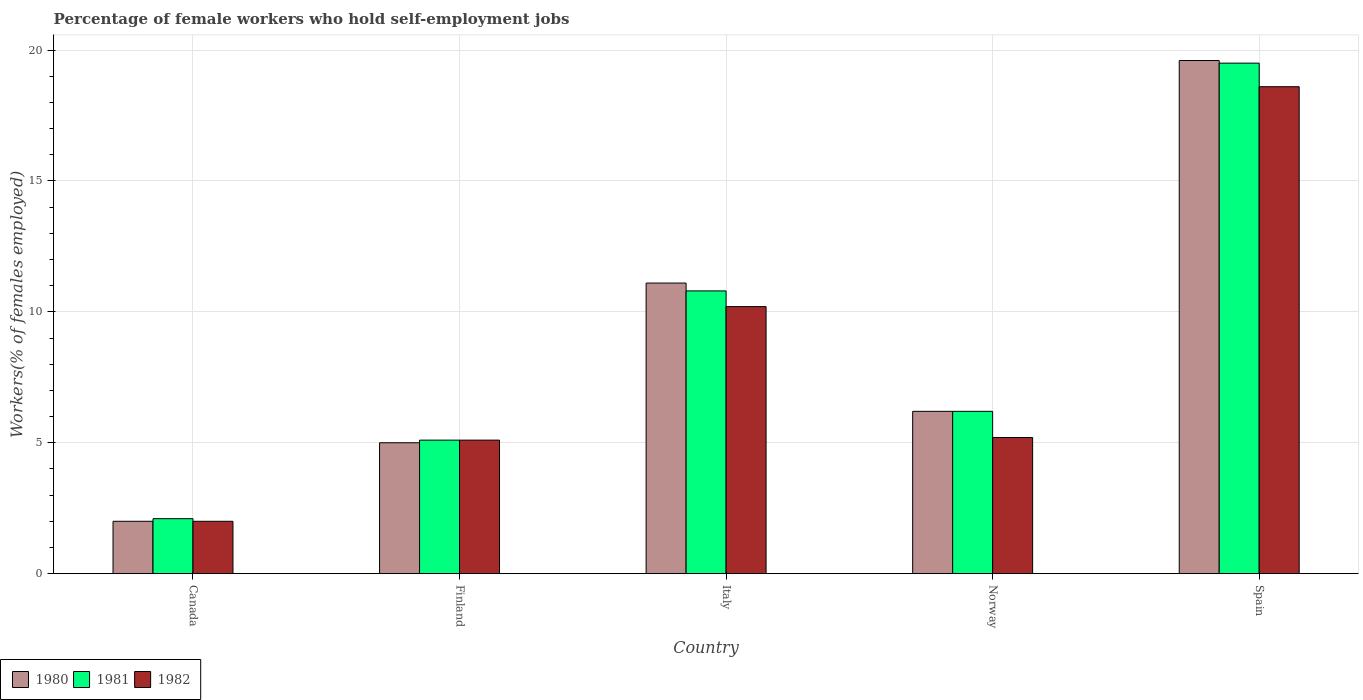Are the number of bars on each tick of the X-axis equal?
Provide a succinct answer. Yes. What is the label of the 2nd group of bars from the left?
Offer a very short reply. Finland. What is the percentage of self-employed female workers in 1980 in Norway?
Provide a succinct answer. 6.2. Across all countries, what is the maximum percentage of self-employed female workers in 1980?
Offer a very short reply. 19.6. Across all countries, what is the minimum percentage of self-employed female workers in 1981?
Provide a short and direct response. 2.1. What is the total percentage of self-employed female workers in 1980 in the graph?
Ensure brevity in your answer.  43.9. What is the difference between the percentage of self-employed female workers in 1980 in Norway and that in Spain?
Provide a succinct answer. -13.4. What is the difference between the percentage of self-employed female workers in 1981 in Spain and the percentage of self-employed female workers in 1980 in Finland?
Ensure brevity in your answer.  14.5. What is the average percentage of self-employed female workers in 1982 per country?
Your answer should be very brief. 8.22. What is the difference between the percentage of self-employed female workers of/in 1982 and percentage of self-employed female workers of/in 1981 in Norway?
Keep it short and to the point. -1. In how many countries, is the percentage of self-employed female workers in 1980 greater than 5 %?
Make the answer very short. 3. What is the ratio of the percentage of self-employed female workers in 1980 in Canada to that in Finland?
Your answer should be compact. 0.4. What is the difference between the highest and the second highest percentage of self-employed female workers in 1980?
Offer a very short reply. -8.5. What is the difference between the highest and the lowest percentage of self-employed female workers in 1981?
Your answer should be compact. 17.4. What does the 3rd bar from the right in Italy represents?
Provide a short and direct response. 1980. How many bars are there?
Offer a very short reply. 15. Are the values on the major ticks of Y-axis written in scientific E-notation?
Give a very brief answer. No. What is the title of the graph?
Offer a terse response. Percentage of female workers who hold self-employment jobs. Does "1974" appear as one of the legend labels in the graph?
Provide a short and direct response. No. What is the label or title of the Y-axis?
Give a very brief answer. Workers(% of females employed). What is the Workers(% of females employed) of 1980 in Canada?
Your answer should be very brief. 2. What is the Workers(% of females employed) of 1981 in Canada?
Make the answer very short. 2.1. What is the Workers(% of females employed) of 1982 in Canada?
Ensure brevity in your answer.  2. What is the Workers(% of females employed) in 1980 in Finland?
Ensure brevity in your answer.  5. What is the Workers(% of females employed) in 1981 in Finland?
Give a very brief answer. 5.1. What is the Workers(% of females employed) in 1982 in Finland?
Your response must be concise. 5.1. What is the Workers(% of females employed) of 1980 in Italy?
Offer a very short reply. 11.1. What is the Workers(% of females employed) of 1981 in Italy?
Your response must be concise. 10.8. What is the Workers(% of females employed) of 1982 in Italy?
Offer a terse response. 10.2. What is the Workers(% of females employed) of 1980 in Norway?
Keep it short and to the point. 6.2. What is the Workers(% of females employed) in 1981 in Norway?
Ensure brevity in your answer.  6.2. What is the Workers(% of females employed) in 1982 in Norway?
Keep it short and to the point. 5.2. What is the Workers(% of females employed) in 1980 in Spain?
Your answer should be compact. 19.6. What is the Workers(% of females employed) in 1981 in Spain?
Your response must be concise. 19.5. What is the Workers(% of females employed) in 1982 in Spain?
Provide a short and direct response. 18.6. Across all countries, what is the maximum Workers(% of females employed) in 1980?
Give a very brief answer. 19.6. Across all countries, what is the maximum Workers(% of females employed) of 1981?
Your response must be concise. 19.5. Across all countries, what is the maximum Workers(% of females employed) of 1982?
Keep it short and to the point. 18.6. Across all countries, what is the minimum Workers(% of females employed) of 1981?
Offer a terse response. 2.1. What is the total Workers(% of females employed) of 1980 in the graph?
Your response must be concise. 43.9. What is the total Workers(% of females employed) in 1981 in the graph?
Make the answer very short. 43.7. What is the total Workers(% of females employed) in 1982 in the graph?
Your answer should be compact. 41.1. What is the difference between the Workers(% of females employed) of 1980 in Canada and that in Italy?
Give a very brief answer. -9.1. What is the difference between the Workers(% of females employed) in 1981 in Canada and that in Italy?
Your response must be concise. -8.7. What is the difference between the Workers(% of females employed) of 1981 in Canada and that in Norway?
Your answer should be very brief. -4.1. What is the difference between the Workers(% of females employed) of 1980 in Canada and that in Spain?
Your response must be concise. -17.6. What is the difference between the Workers(% of females employed) in 1981 in Canada and that in Spain?
Your answer should be compact. -17.4. What is the difference between the Workers(% of females employed) of 1982 in Canada and that in Spain?
Your answer should be very brief. -16.6. What is the difference between the Workers(% of females employed) of 1981 in Finland and that in Italy?
Keep it short and to the point. -5.7. What is the difference between the Workers(% of females employed) in 1980 in Finland and that in Norway?
Your answer should be very brief. -1.2. What is the difference between the Workers(% of females employed) in 1981 in Finland and that in Norway?
Offer a terse response. -1.1. What is the difference between the Workers(% of females employed) in 1980 in Finland and that in Spain?
Your answer should be compact. -14.6. What is the difference between the Workers(% of females employed) in 1981 in Finland and that in Spain?
Keep it short and to the point. -14.4. What is the difference between the Workers(% of females employed) in 1982 in Finland and that in Spain?
Offer a terse response. -13.5. What is the difference between the Workers(% of females employed) of 1980 in Italy and that in Norway?
Offer a very short reply. 4.9. What is the difference between the Workers(% of females employed) in 1982 in Italy and that in Spain?
Offer a terse response. -8.4. What is the difference between the Workers(% of females employed) of 1982 in Norway and that in Spain?
Offer a terse response. -13.4. What is the difference between the Workers(% of females employed) of 1980 in Canada and the Workers(% of females employed) of 1981 in Finland?
Keep it short and to the point. -3.1. What is the difference between the Workers(% of females employed) of 1981 in Canada and the Workers(% of females employed) of 1982 in Finland?
Provide a short and direct response. -3. What is the difference between the Workers(% of females employed) in 1980 in Canada and the Workers(% of females employed) in 1981 in Norway?
Make the answer very short. -4.2. What is the difference between the Workers(% of females employed) of 1980 in Canada and the Workers(% of females employed) of 1982 in Norway?
Your answer should be compact. -3.2. What is the difference between the Workers(% of females employed) in 1980 in Canada and the Workers(% of females employed) in 1981 in Spain?
Your answer should be very brief. -17.5. What is the difference between the Workers(% of females employed) of 1980 in Canada and the Workers(% of females employed) of 1982 in Spain?
Make the answer very short. -16.6. What is the difference between the Workers(% of females employed) in 1981 in Canada and the Workers(% of females employed) in 1982 in Spain?
Keep it short and to the point. -16.5. What is the difference between the Workers(% of females employed) in 1980 in Finland and the Workers(% of females employed) in 1982 in Norway?
Provide a short and direct response. -0.2. What is the difference between the Workers(% of females employed) of 1981 in Finland and the Workers(% of females employed) of 1982 in Norway?
Your answer should be compact. -0.1. What is the difference between the Workers(% of females employed) in 1980 in Finland and the Workers(% of females employed) in 1982 in Spain?
Your response must be concise. -13.6. What is the difference between the Workers(% of females employed) of 1981 in Finland and the Workers(% of females employed) of 1982 in Spain?
Ensure brevity in your answer.  -13.5. What is the difference between the Workers(% of females employed) in 1980 in Italy and the Workers(% of females employed) in 1981 in Norway?
Your answer should be compact. 4.9. What is the difference between the Workers(% of females employed) in 1980 in Italy and the Workers(% of females employed) in 1982 in Norway?
Provide a succinct answer. 5.9. What is the difference between the Workers(% of females employed) in 1980 in Italy and the Workers(% of females employed) in 1981 in Spain?
Your response must be concise. -8.4. What is the difference between the Workers(% of females employed) of 1980 in Italy and the Workers(% of females employed) of 1982 in Spain?
Your answer should be very brief. -7.5. What is the difference between the Workers(% of females employed) of 1980 in Norway and the Workers(% of females employed) of 1982 in Spain?
Your answer should be compact. -12.4. What is the difference between the Workers(% of females employed) in 1981 in Norway and the Workers(% of females employed) in 1982 in Spain?
Ensure brevity in your answer.  -12.4. What is the average Workers(% of females employed) in 1980 per country?
Ensure brevity in your answer.  8.78. What is the average Workers(% of females employed) in 1981 per country?
Provide a succinct answer. 8.74. What is the average Workers(% of females employed) in 1982 per country?
Offer a very short reply. 8.22. What is the difference between the Workers(% of females employed) of 1980 and Workers(% of females employed) of 1981 in Canada?
Give a very brief answer. -0.1. What is the difference between the Workers(% of females employed) of 1980 and Workers(% of females employed) of 1982 in Canada?
Ensure brevity in your answer.  0. What is the difference between the Workers(% of females employed) of 1981 and Workers(% of females employed) of 1982 in Canada?
Provide a succinct answer. 0.1. What is the difference between the Workers(% of females employed) of 1980 and Workers(% of females employed) of 1981 in Finland?
Make the answer very short. -0.1. What is the difference between the Workers(% of females employed) in 1980 and Workers(% of females employed) in 1981 in Italy?
Your answer should be very brief. 0.3. What is the difference between the Workers(% of females employed) in 1980 and Workers(% of females employed) in 1982 in Italy?
Give a very brief answer. 0.9. What is the difference between the Workers(% of females employed) in 1981 and Workers(% of females employed) in 1982 in Norway?
Ensure brevity in your answer.  1. What is the difference between the Workers(% of females employed) of 1980 and Workers(% of females employed) of 1982 in Spain?
Offer a terse response. 1. What is the difference between the Workers(% of females employed) in 1981 and Workers(% of females employed) in 1982 in Spain?
Your answer should be very brief. 0.9. What is the ratio of the Workers(% of females employed) of 1980 in Canada to that in Finland?
Offer a terse response. 0.4. What is the ratio of the Workers(% of females employed) in 1981 in Canada to that in Finland?
Give a very brief answer. 0.41. What is the ratio of the Workers(% of females employed) in 1982 in Canada to that in Finland?
Keep it short and to the point. 0.39. What is the ratio of the Workers(% of females employed) in 1980 in Canada to that in Italy?
Your answer should be compact. 0.18. What is the ratio of the Workers(% of females employed) of 1981 in Canada to that in Italy?
Offer a terse response. 0.19. What is the ratio of the Workers(% of females employed) in 1982 in Canada to that in Italy?
Offer a very short reply. 0.2. What is the ratio of the Workers(% of females employed) in 1980 in Canada to that in Norway?
Provide a succinct answer. 0.32. What is the ratio of the Workers(% of females employed) of 1981 in Canada to that in Norway?
Keep it short and to the point. 0.34. What is the ratio of the Workers(% of females employed) of 1982 in Canada to that in Norway?
Give a very brief answer. 0.38. What is the ratio of the Workers(% of females employed) in 1980 in Canada to that in Spain?
Provide a succinct answer. 0.1. What is the ratio of the Workers(% of females employed) of 1981 in Canada to that in Spain?
Ensure brevity in your answer.  0.11. What is the ratio of the Workers(% of females employed) of 1982 in Canada to that in Spain?
Keep it short and to the point. 0.11. What is the ratio of the Workers(% of females employed) of 1980 in Finland to that in Italy?
Ensure brevity in your answer.  0.45. What is the ratio of the Workers(% of females employed) in 1981 in Finland to that in Italy?
Give a very brief answer. 0.47. What is the ratio of the Workers(% of females employed) of 1982 in Finland to that in Italy?
Your answer should be compact. 0.5. What is the ratio of the Workers(% of females employed) in 1980 in Finland to that in Norway?
Provide a succinct answer. 0.81. What is the ratio of the Workers(% of females employed) of 1981 in Finland to that in Norway?
Keep it short and to the point. 0.82. What is the ratio of the Workers(% of females employed) of 1982 in Finland to that in Norway?
Offer a very short reply. 0.98. What is the ratio of the Workers(% of females employed) of 1980 in Finland to that in Spain?
Provide a short and direct response. 0.26. What is the ratio of the Workers(% of females employed) of 1981 in Finland to that in Spain?
Provide a succinct answer. 0.26. What is the ratio of the Workers(% of females employed) of 1982 in Finland to that in Spain?
Offer a very short reply. 0.27. What is the ratio of the Workers(% of females employed) in 1980 in Italy to that in Norway?
Keep it short and to the point. 1.79. What is the ratio of the Workers(% of females employed) of 1981 in Italy to that in Norway?
Offer a very short reply. 1.74. What is the ratio of the Workers(% of females employed) of 1982 in Italy to that in Norway?
Make the answer very short. 1.96. What is the ratio of the Workers(% of females employed) in 1980 in Italy to that in Spain?
Provide a succinct answer. 0.57. What is the ratio of the Workers(% of females employed) of 1981 in Italy to that in Spain?
Your answer should be very brief. 0.55. What is the ratio of the Workers(% of females employed) of 1982 in Italy to that in Spain?
Your answer should be very brief. 0.55. What is the ratio of the Workers(% of females employed) of 1980 in Norway to that in Spain?
Provide a succinct answer. 0.32. What is the ratio of the Workers(% of females employed) of 1981 in Norway to that in Spain?
Your response must be concise. 0.32. What is the ratio of the Workers(% of females employed) of 1982 in Norway to that in Spain?
Your answer should be compact. 0.28. What is the difference between the highest and the second highest Workers(% of females employed) in 1982?
Offer a terse response. 8.4. What is the difference between the highest and the lowest Workers(% of females employed) of 1981?
Provide a short and direct response. 17.4. 